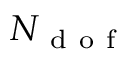Convert formula to latex. <formula><loc_0><loc_0><loc_500><loc_500>N _ { d o f }</formula> 